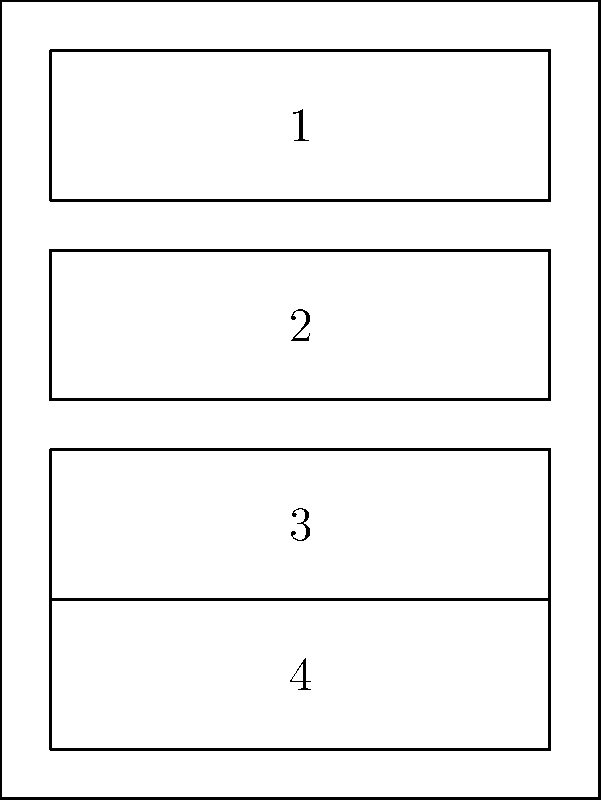In a secure office at the State Capitol, there's a file cabinet with 4 drawers as shown in the diagram. The drawers can be rearranged in different orders for security purposes. How many unique permutations of the drawer arrangement are possible, and what is the order of the permutation group formed by these arrangements? To solve this problem, we'll follow these steps:

1. Identify the group: The group in question is the permutation group of 4 elements (the drawers).

2. Calculate the number of permutations:
   - For 4 distinct elements, the number of permutations is given by 4! (4 factorial).
   - 4! = 4 × 3 × 2 × 1 = 24

3. Determine the order of the group:
   - The order of a group is the number of elements in the group.
   - In this case, each permutation is an element of the group.
   - Therefore, the order of the group is equal to the number of permutations.

4. Express the group mathematically:
   - This permutation group is isomorphic to the symmetric group $S_4$.
   - It can be denoted as $Sym(4)$ or $S_4$.

5. Properties of $S_4$:
   - It is not abelian (commutative) for $n \geq 3$.
   - It contains both even and odd permutations.
   - Its subgroups include $A_4$ (alternating group on 4 elements), $D_4$ (dihedral group of order 8), and $C_4$ (cyclic group of order 4), among others.

Therefore, there are 24 unique permutations possible, and the order of the permutation group ($$S_4$$) is also 24.
Answer: 24 permutations; order 24 